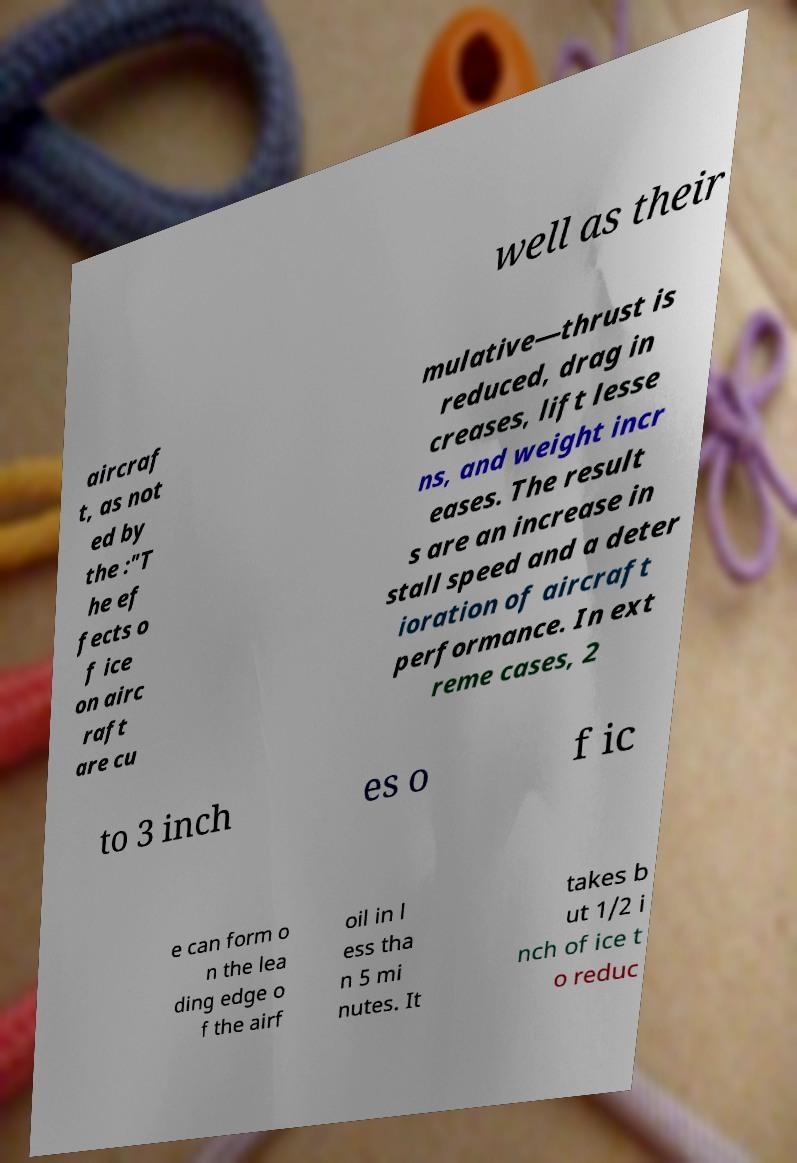I need the written content from this picture converted into text. Can you do that? well as their aircraf t, as not ed by the :"T he ef fects o f ice on airc raft are cu mulative—thrust is reduced, drag in creases, lift lesse ns, and weight incr eases. The result s are an increase in stall speed and a deter ioration of aircraft performance. In ext reme cases, 2 to 3 inch es o f ic e can form o n the lea ding edge o f the airf oil in l ess tha n 5 mi nutes. It takes b ut 1/2 i nch of ice t o reduc 